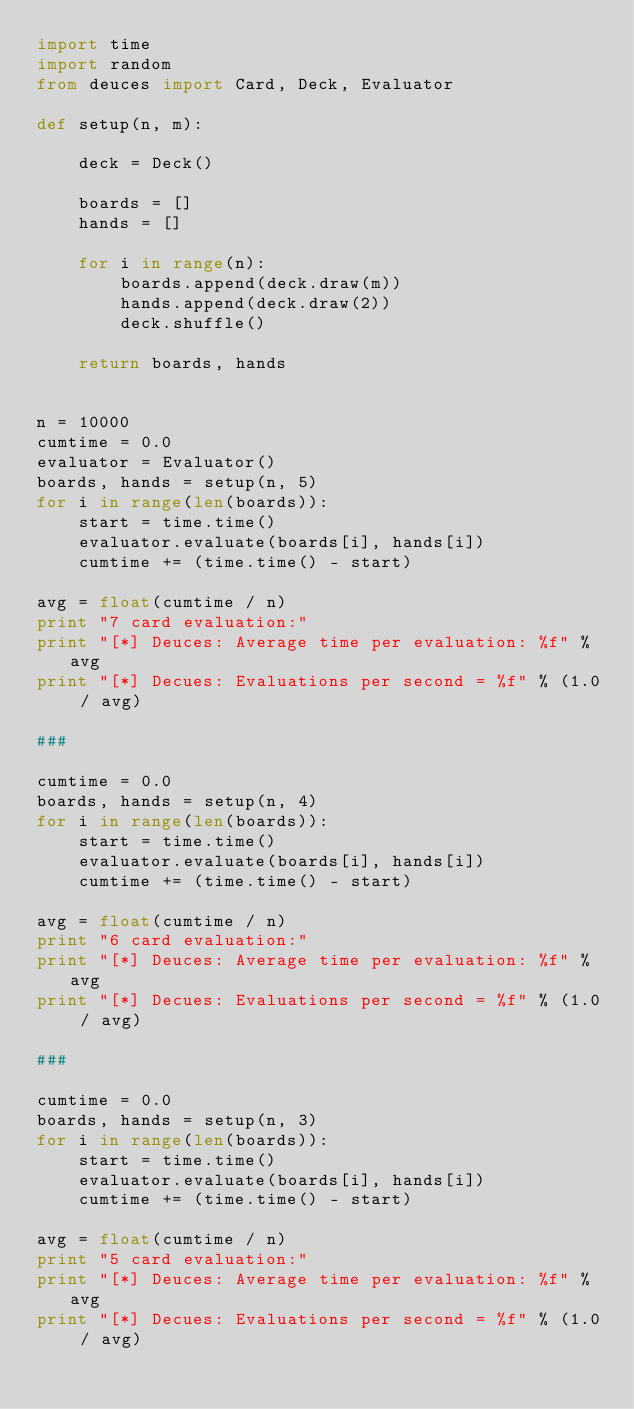<code> <loc_0><loc_0><loc_500><loc_500><_Python_>import time
import random
from deuces import Card, Deck, Evaluator

def setup(n, m):

    deck = Deck()

    boards = []
    hands = []

    for i in range(n):
        boards.append(deck.draw(m))
        hands.append(deck.draw(2))
        deck.shuffle()

    return boards, hands


n = 10000
cumtime = 0.0
evaluator = Evaluator()
boards, hands = setup(n, 5)
for i in range(len(boards)):
    start = time.time()
    evaluator.evaluate(boards[i], hands[i])
    cumtime += (time.time() - start)

avg = float(cumtime / n)
print "7 card evaluation:"
print "[*] Deuces: Average time per evaluation: %f" % avg
print "[*] Decues: Evaluations per second = %f" % (1.0 / avg)

###

cumtime = 0.0
boards, hands = setup(n, 4)
for i in range(len(boards)):
    start = time.time()
    evaluator.evaluate(boards[i], hands[i])
    cumtime += (time.time() - start)

avg = float(cumtime / n)
print "6 card evaluation:"
print "[*] Deuces: Average time per evaluation: %f" % avg
print "[*] Decues: Evaluations per second = %f" % (1.0 / avg)

###

cumtime = 0.0
boards, hands = setup(n, 3)
for i in range(len(boards)):
    start = time.time()
    evaluator.evaluate(boards[i], hands[i])
    cumtime += (time.time() - start)

avg = float(cumtime / n)
print "5 card evaluation:"
print "[*] Deuces: Average time per evaluation: %f" % avg
print "[*] Decues: Evaluations per second = %f" % (1.0 / avg)
</code> 